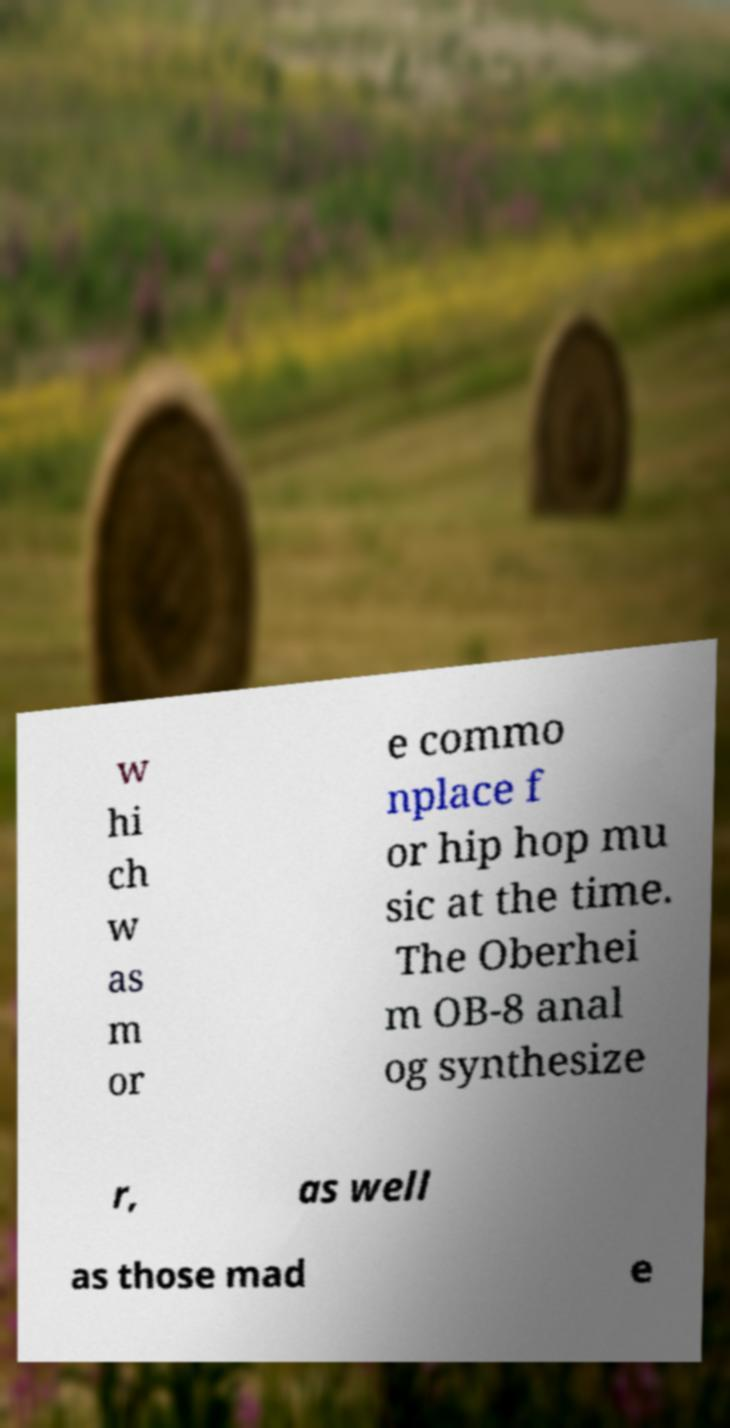There's text embedded in this image that I need extracted. Can you transcribe it verbatim? w hi ch w as m or e commo nplace f or hip hop mu sic at the time. The Oberhei m OB-8 anal og synthesize r, as well as those mad e 